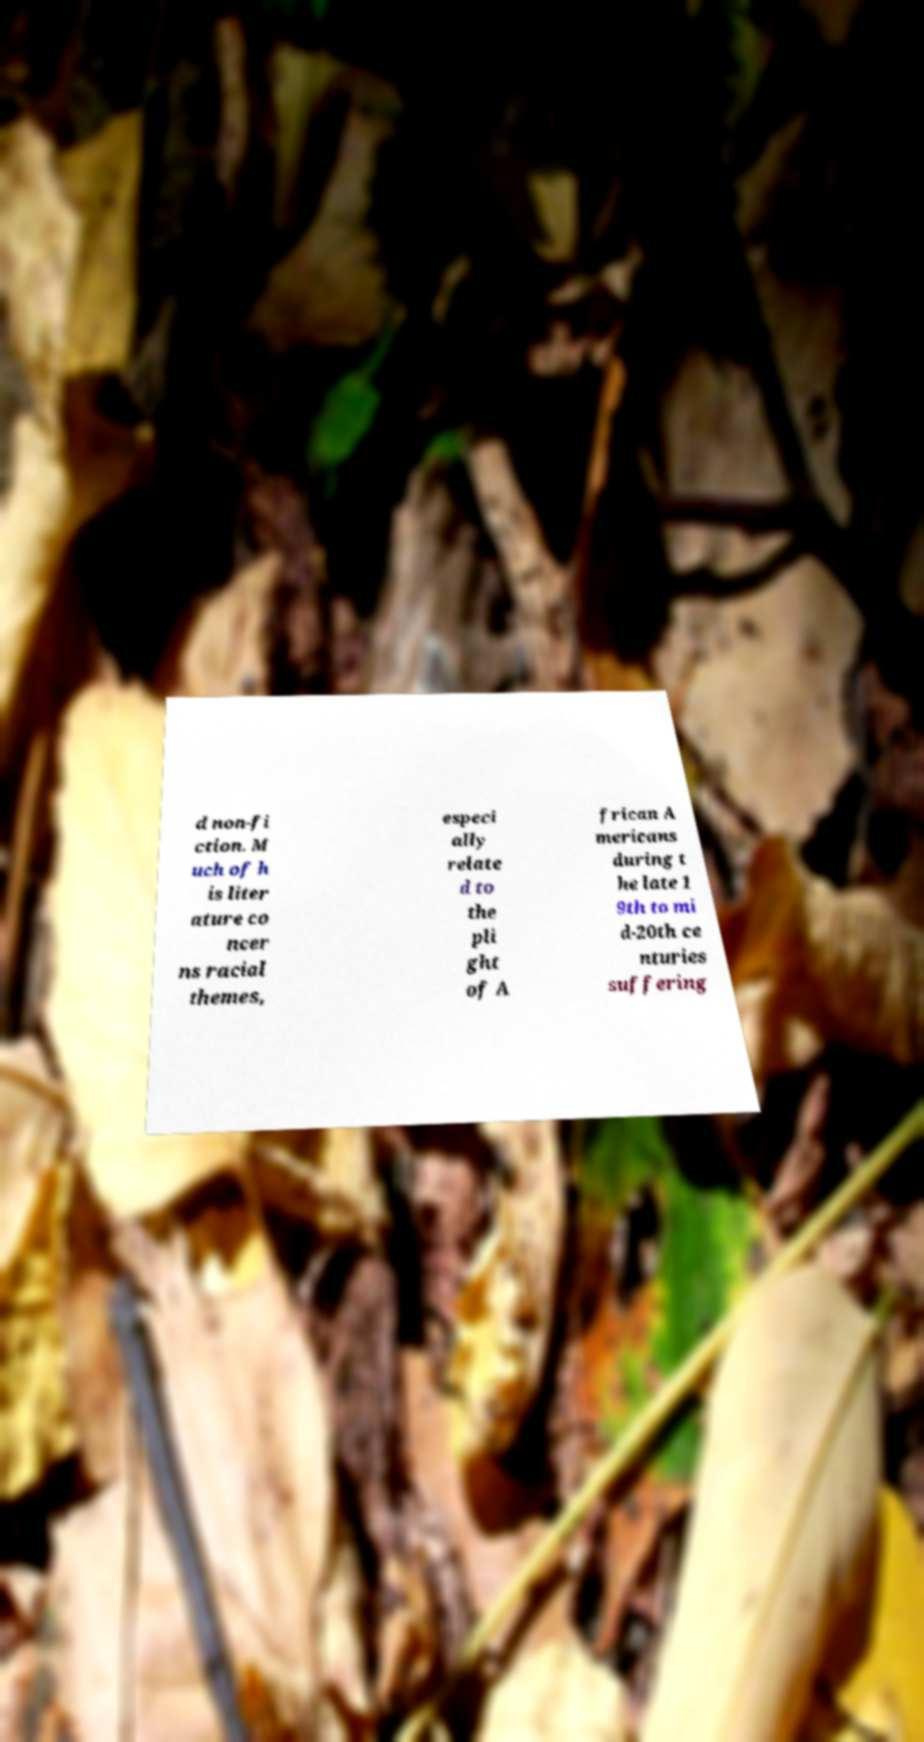Could you assist in decoding the text presented in this image and type it out clearly? d non-fi ction. M uch of h is liter ature co ncer ns racial themes, especi ally relate d to the pli ght of A frican A mericans during t he late 1 9th to mi d-20th ce nturies suffering 